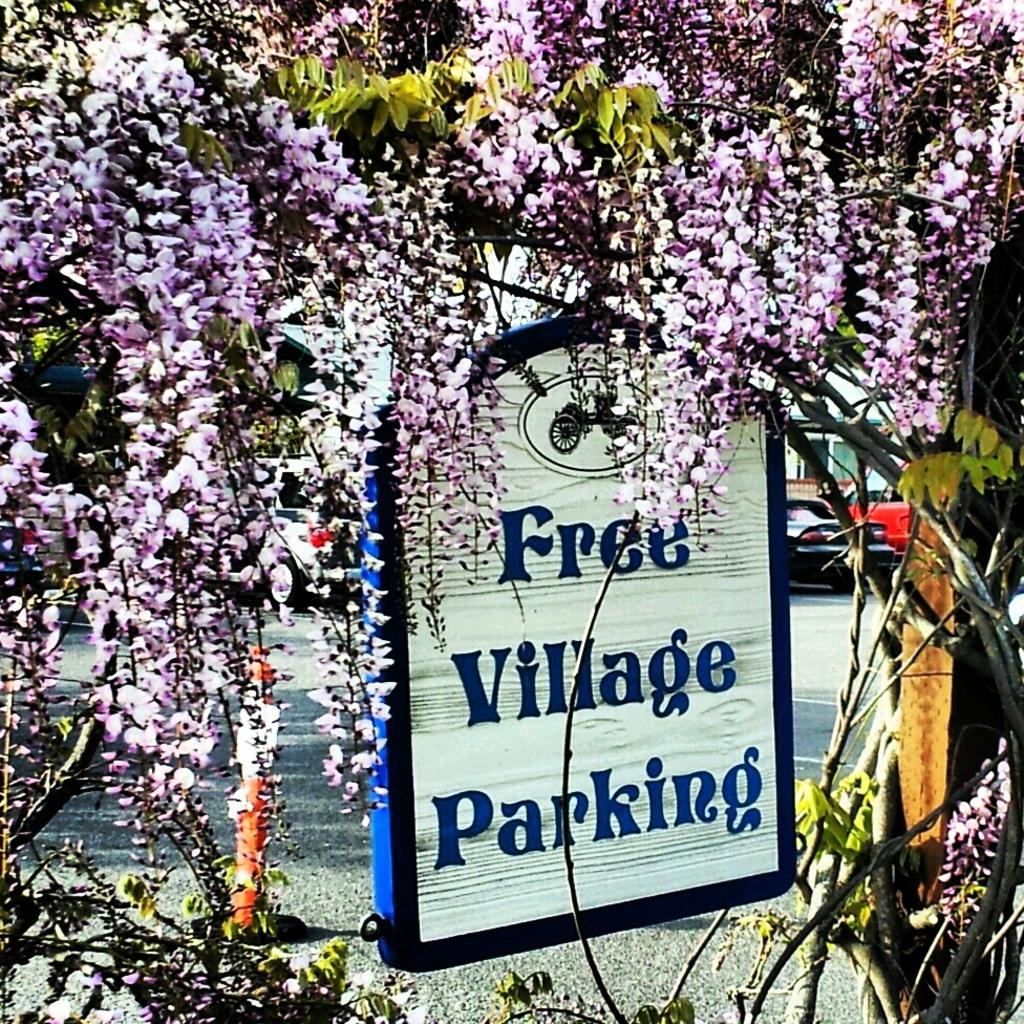What type of natural elements can be seen in the image? There are trees and plants in the image. What else can be seen in the image besides natural elements? There are vehicles, an object on the ground, a wooden pole, and a board with an image and text in the image. What is the surface visible in the image? The ground is visible in the image. Can you describe the board with an image and text in the image? Yes, it is a board with an image and text in the image. What is the opinion of the trees in the image? Trees do not have opinions, as they are inanimate objects. Is there a playground visible in the image? There is no mention of a playground in the provided facts, so it cannot be determined if one is present in the image. 